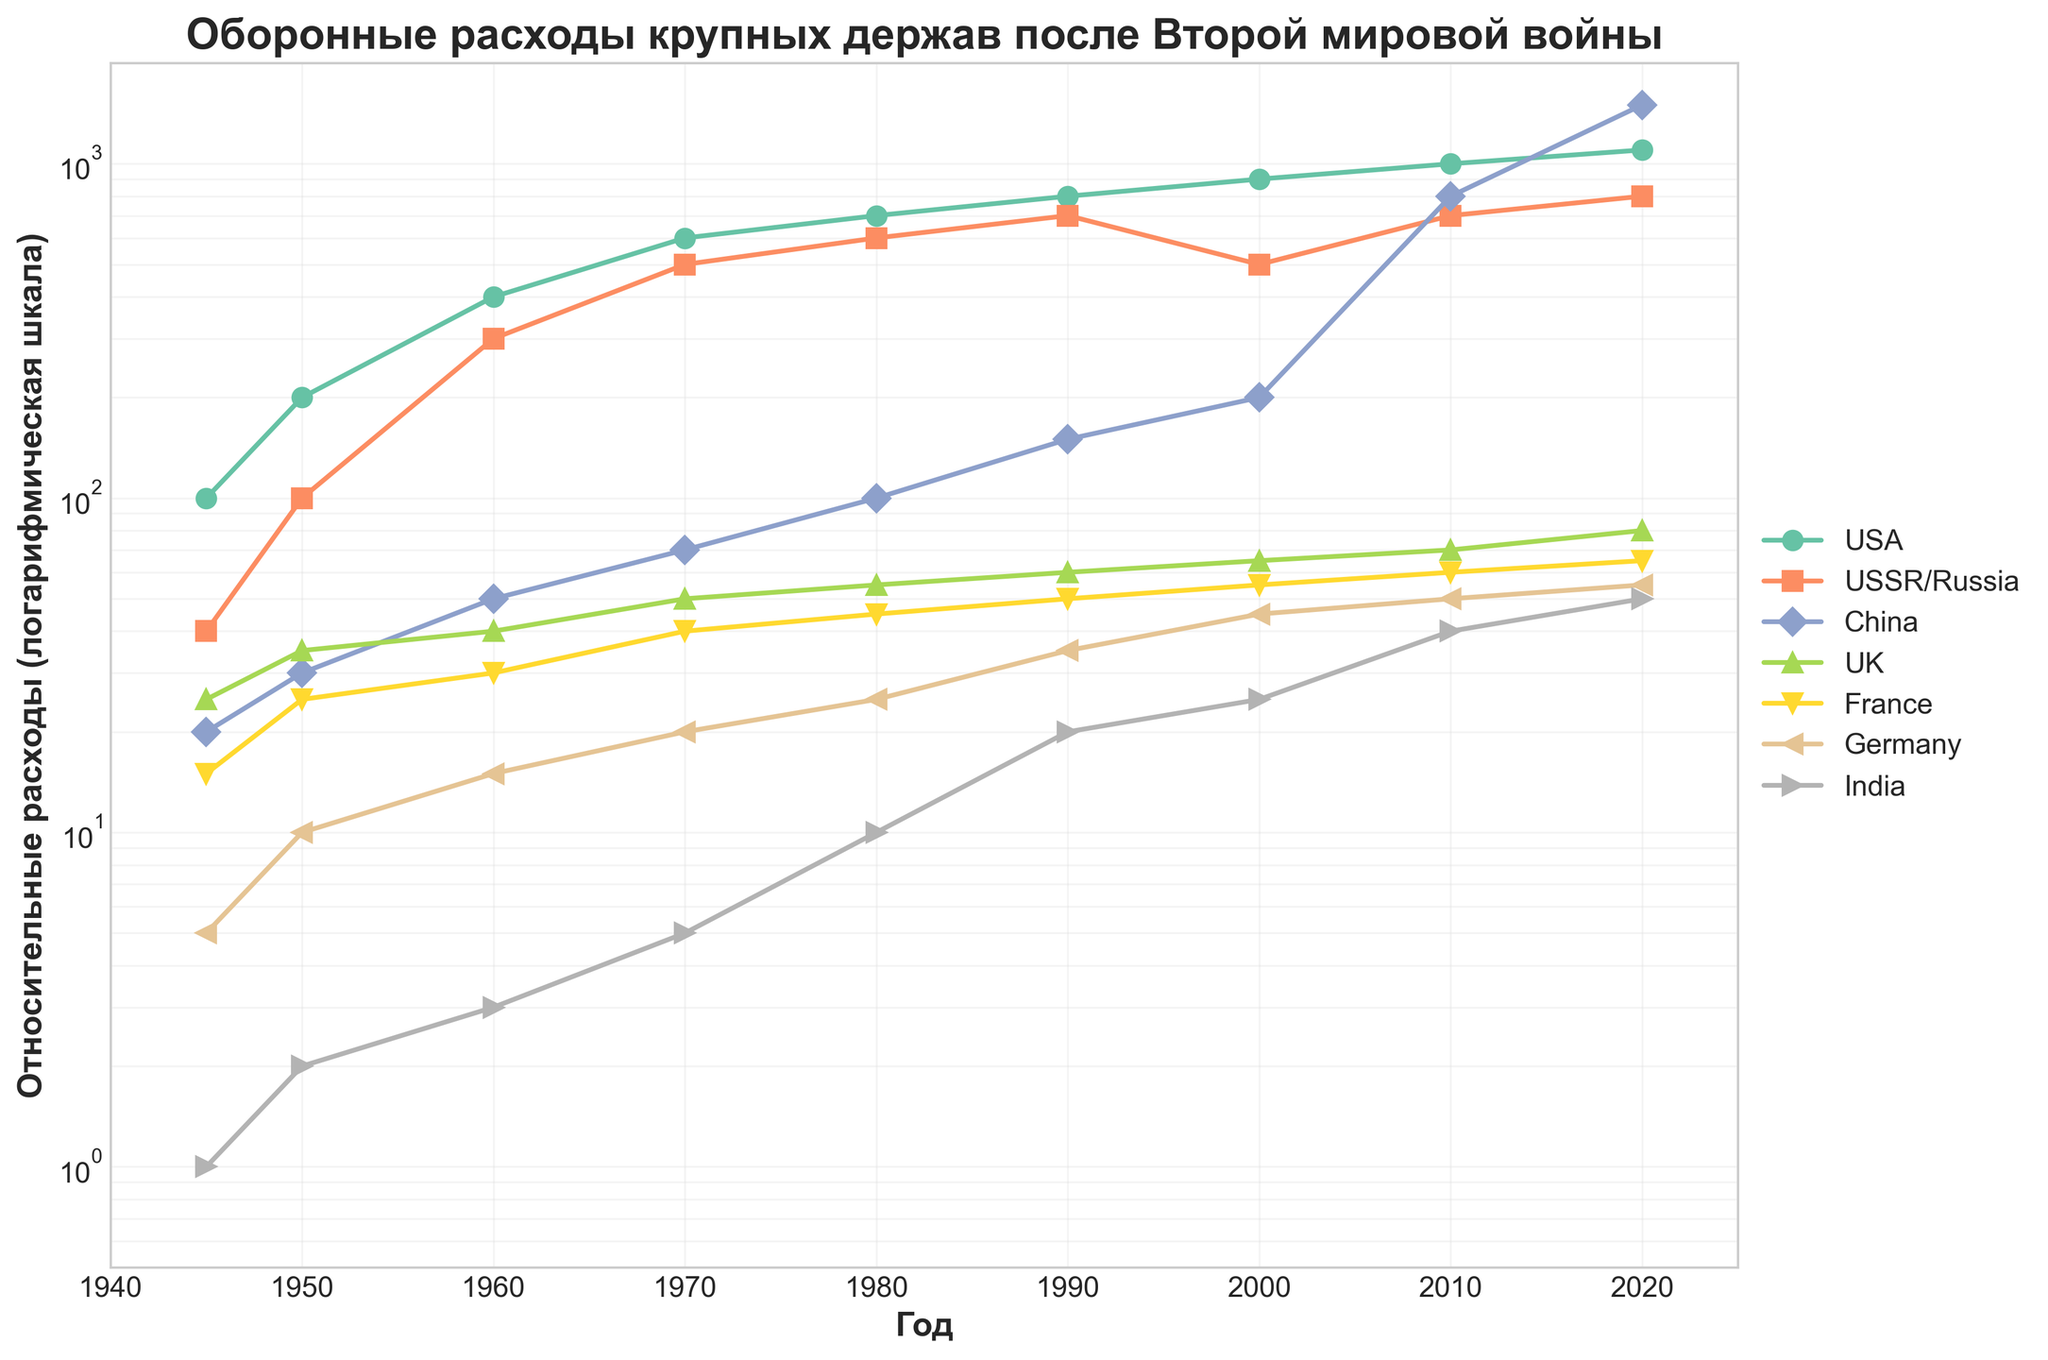Which country shows the highest defense expenditure in 2020? In the year 2020, the line representing China reaches the highest value on the log scale, indicating that China has the highest defense expenditure among the countries listed.
Answer: China What is the title of the figure? The title of the figure is written at the top of the plot. It reads: "Оборонные расходы крупных держав после Второй мировой войны".
Answer: Оборонные расходы крупных держав после Второй мировой войны How do the defense expenditures of the USA and USSR/Russia compare in 1980? The defense expenditure of the USA in 1980 is higher than that of the USSR/Russia. The corresponding points on the graph show that the USA's expenditure is around 700, while the USSR/Russia's is around 600.
Answer: USA's expenditure is higher Between which years did China's defense expenditure increase the most? To answer this, observe the slope of China's line on the plot. The steepest increase can be seen between 2010 and 2020, where it jumps from 800 to 1500.
Answer: Between 2010 and 2020 Which countries had a higher defense expenditure than France in 1950? Referring to the plotted lines at the year 1950, the countries with higher values than France (25.0) are the USA (200.0) and USSR/Russia (100.0).
Answer: USA, USSR/Russia What is the range of the y-axis on the plot? The y-axis range, as indicated by the plot limits, spans from approximately 0.5 to 2000 on a logarithmic scale.
Answer: 0.5 to 2000 Did Germany's defense expenditure ever surpass that of the UK from 1945 to 2020? By tracing the lines for Germany and the UK from 1945 through 2020, it is clear that Germany's expenditure remains below that of the UK's throughout the given time period.
Answer: No Which years mark the initiation and termination points in the plot, and what is their significance? The x-axis starts at the year 1945 and ends at 2020, representing the end of World War II and the present time or the latest data available in the dataset.
Answer: 1945 and 2020 Identify the country with the smallest defense expenditure in 1960. In 1960, the plot shows that India's defense expenditure (3.0) is the smallest among the nations listed.
Answer: India How does France's defense expenditure change from 1950 to 1960? From 1950 to 1960, France's defense expenditure increases from about 25.0 to 30.0, shown by the upward trend of the line representing France.
Answer: It increases 